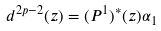Convert formula to latex. <formula><loc_0><loc_0><loc_500><loc_500>d ^ { 2 p - 2 } ( z ) = ( P ^ { 1 } ) ^ { * } ( z ) \alpha _ { 1 }</formula> 